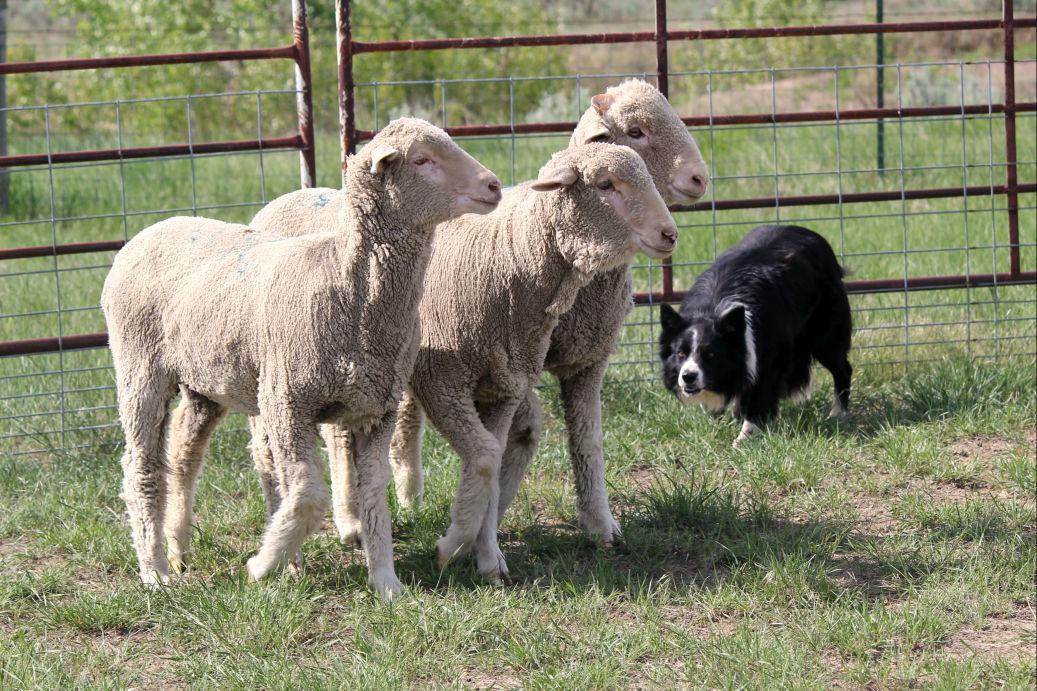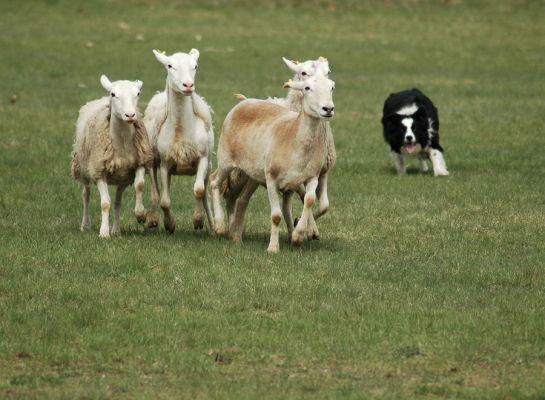The first image is the image on the left, the second image is the image on the right. For the images shown, is this caption "An image shows the dog in profile, centered in front of a group of animals." true? Answer yes or no. No. The first image is the image on the left, the second image is the image on the right. Considering the images on both sides, is "The sheep in the image on the left have been shorn." valid? Answer yes or no. Yes. The first image is the image on the left, the second image is the image on the right. Considering the images on both sides, is "An image shows a dog at the right herding no more than three sheep, which are at the left." valid? Answer yes or no. Yes. 